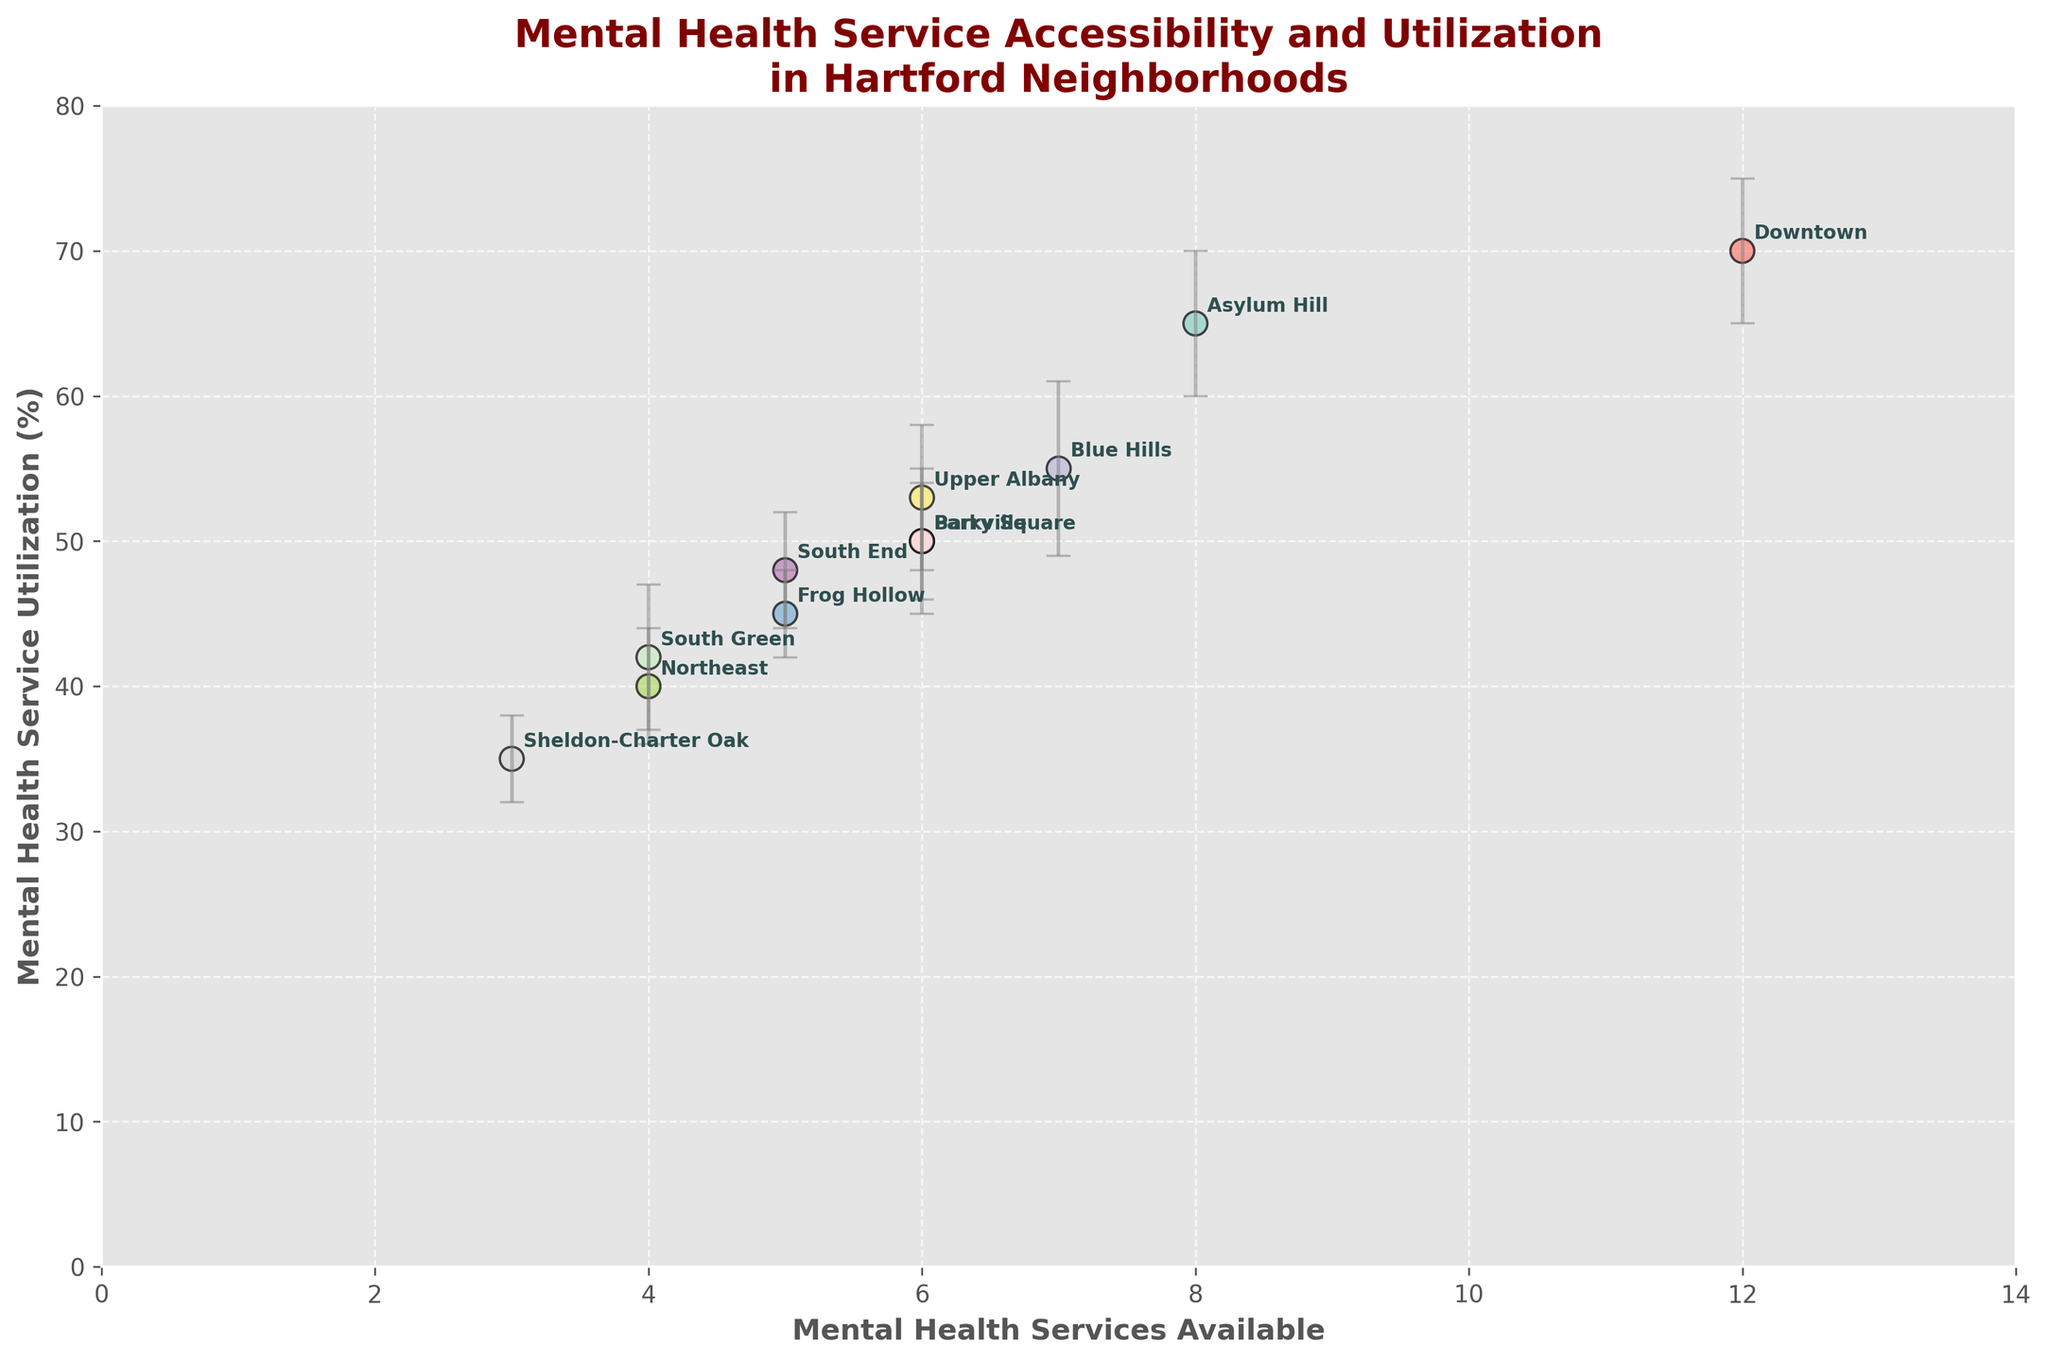What's the title of the figure? The title of the figure is usually located at the top and summarizes the content of the plot.
Answer: Mental Health Service Accessibility and Utilization in Hartford Neighborhoods Which neighborhood has the highest mental health service utilization? By looking at the y-axis which represents the mental health service utilization and then finding the highest point, we can determine the neighborhood.
Answer: Downtown What is the mental health service availability for Blue Hills? Find Blue Hills in the plot and look at the x-axis value corresponding to it.
Answer: 7 How many mental health services are available in the neighborhood with the lowest utilization? First, locate the neighborhood with the lowest utilization on the y-axis, which is Sheldon-Charter Oak. Then, check the value on the x-axis for service availability.
Answer: 3 Which neighborhoods have the same number of mental health services available? Check for neighborhoods that align on the x-axis. Both Upper Albany and Barry Square have 6 services available. Also, Barry Square and Parkville have 6 services available. Thus, Barry Square, Upper Albany, and Parkville all have the same number of services available.
Answer: Barry Square, Upper Albany, Parkville Is there a neighborhood with both high service availability and high utilization? Look for neighborhoods that are positioned towards the top right of the plot since high values on both axes indicate high availability and high utilization.
Answer: Downtown What’s the difference in mental health service utilization between Frog Hollow and South End? First, find the points for Frog Hollow and South End on the plot and note their y-axis values (45% and 48%, respectively). Subtract the smaller value from the larger one: 48 - 45.
Answer: 3 Which neighborhoods have the smallest error bars for service utilization? Identify the points with the shortest vertical error bars. Both Frog Hollow and Sheldon-Charter Oak have error bars of 3.
Answer: Frog Hollow, Sheldon-Charter Oak Is there a trend that indicates neighborhoods with fewer services have lower utilization? Look at the overall distribution of points. If neighborhoods with fewer services (left side of x-axis) are generally lower on the y-axis, then there is such a trend. This pattern is somewhat visible in the plot, especially for neighborhoods like Sheldon-Charter Oak and Northeast.
Answer: Yes, somewhat Compare mental health service utilization between Asylum Hill and Blue Hills. Which one is higher and by how much? Identify their positions on the y-axis (Asylum Hill at 65% and Blue Hills at 55%). Subtract the smaller value from the larger one: 65 - 55.
Answer: Asylum Hill is higher by 10 